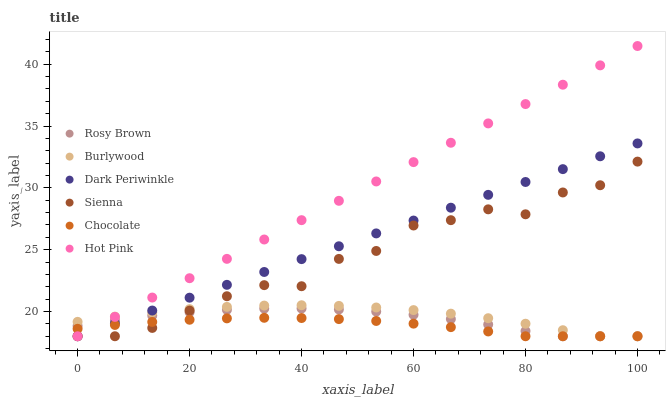Does Chocolate have the minimum area under the curve?
Answer yes or no. Yes. Does Hot Pink have the maximum area under the curve?
Answer yes or no. Yes. Does Burlywood have the minimum area under the curve?
Answer yes or no. No. Does Burlywood have the maximum area under the curve?
Answer yes or no. No. Is Dark Periwinkle the smoothest?
Answer yes or no. Yes. Is Sienna the roughest?
Answer yes or no. Yes. Is Burlywood the smoothest?
Answer yes or no. No. Is Burlywood the roughest?
Answer yes or no. No. Does Rosy Brown have the lowest value?
Answer yes or no. Yes. Does Hot Pink have the highest value?
Answer yes or no. Yes. Does Burlywood have the highest value?
Answer yes or no. No. Does Hot Pink intersect Dark Periwinkle?
Answer yes or no. Yes. Is Hot Pink less than Dark Periwinkle?
Answer yes or no. No. Is Hot Pink greater than Dark Periwinkle?
Answer yes or no. No. 